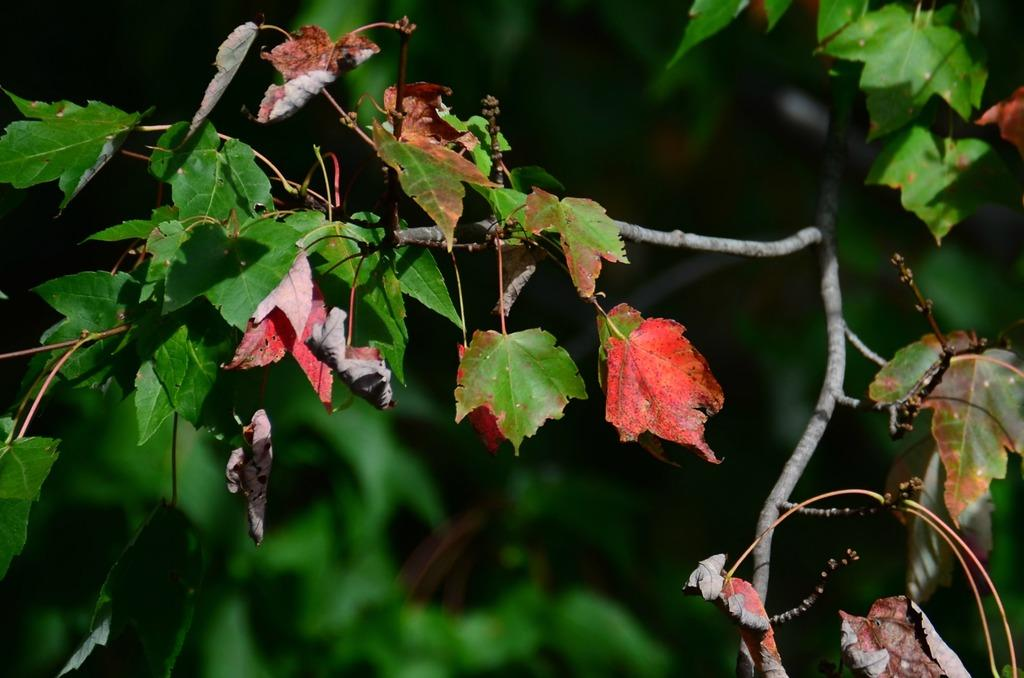What is the main subject of the image? The main subject of the image is a stem of a plant. What part of the plant is visible in the image? The stem has leaves in the image. How many legs can be seen on the plant in the image? Plants do not have legs, so there are no legs visible in the image. 